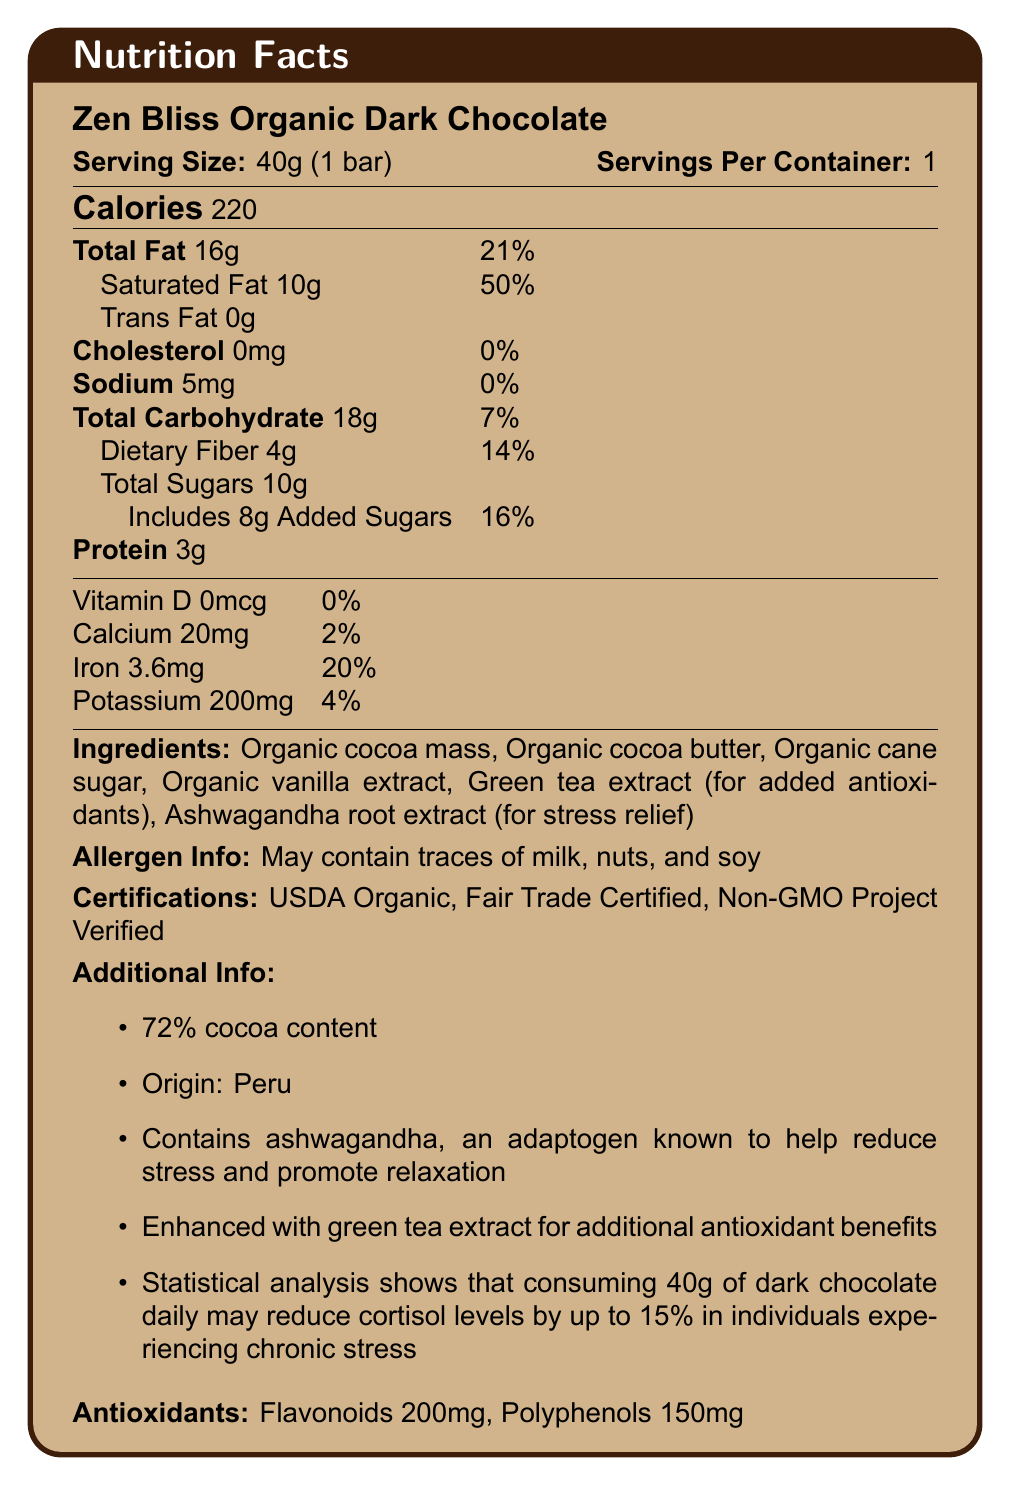what is the serving size of Zen Bliss Organic Dark Chocolate? The serving size is clearly stated at the beginning of the document as "Serving Size: 40g (1 bar)".
Answer: 40g (1 bar) how many calories are in one serving of Zen Bliss Organic Dark Chocolate? The calorie content per serving is listed as "Calories: 220" in the document.
Answer: 220 what are the antioxidants present in the chocolate bar and their amounts? Under the section titled "Antioxidants", it lists "Flavonoids: 200mg" and "Polyphenols: 150mg".
Answer: Flavonoids: 200mg, Polyphenols: 150mg what is the percentage daily value of iron in the chocolate bar? The daily value of iron is indicated as "Iron 3.6mg: 20%" in the nutritional information section.
Answer: 20% how much added sugars does the chocolate bar contain? The document specifies "Includes 8g Added Sugars" in the carbohydrate details.
Answer: 8g does the chocolate bar contain any cholesterol? The entry for cholesterol states "Cholesterol 0mg: 0%" indicating that it contains no cholesterol.
Answer: No which of the following ingredients is added for stress relief? A. Organic cane sugar B. Green tea extract C. Ashwagandha root extract D. Organic vanilla extract Ashwagandha root extract is noted for its stress relief properties in the ingredients list and additional info.
Answer: C. Ashwagandha root extract which certifications does the Zen Bliss Organic Dark Chocolate have? A. USDA Organic, Fair Trade Certified B. USDA Organic, Gluten-Free C. Fair Trade Certified, Non-GMO Project Verified D. USDA Organic, Fair Trade Certified, Non-GMO Project Verified The document lists "USDA Organic, Fair Trade Certified, Non-GMO Project Verified" under the Certifications section.
Answer: D is there any trans fat in the chocolate bar? The document explicitly states "Trans Fat 0g", indicating there is no trans fat.
Answer: No summarize the main information of Zen Bliss Organic Dark Chocolate. This summary covers all the major components including nutritional information, ingredients, added benefits, allergens, and certifications.
Answer: Zen Bliss Organic Dark Chocolate is an organic, fair trade certified dark chocolate bar with 72% cocoa content. Each 40g serving contains 220 calories, 16g total fat (50% of which is saturated), and no cholesterol. It includes 18g of carbohydrates, 4g of dietary fiber, and 10g of sugars (with 8g of added sugars). It also contains antioxidants like flavonoids (200mg) and polyphenols (150mg), enhanced with green tea extract for added antioxidant benefits and ashwagandha for stress relief. The bar is made with ingredients like organic cocoa mass, cocoa butter, and cane sugar, and may contain traces of milk, nuts, and soy. where is the country of origin for Zen Bliss Organic Dark Chocolate? The country of origin is listed under "Additional Info" as "Origin: Peru".
Answer: Peru what is the cocoa content of Zen Bliss Organic Dark Chocolate? The cocoa content is specified as "72%" under the Additional Info section.
Answer: 72% how does consuming 40g of the chocolate bar daily impact cortisol levels? The document mentions that statistical analysis shows a 15% reduction in cortisol levels may occur in individuals experiencing chronic stress who consume 40g of the chocolate daily.
Answer: May reduce cortisol levels by up to 15% what is the daily percentage value of potassium in the chocolate bar? The daily value of potassium is listed as "Potassium 200mg: 4%".
Answer: 4% how much saturated fat is in the chocolate bar per serving? The amount of saturated fat per serving is noted as "Saturated Fat 10g" in the nutritional information.
Answer: 10g what benefits does ashwagandha in the chocolate bar provide? According to the "Additional Info" section, ashwagandha is an adaptogen known to help reduce stress and promote relaxation.
Answer: Stress relief and promotes relaxation does the document mention the effect of Zen Bliss Organic Dark Chocolate on weight loss? The document does not mention any information regarding weight loss.
Answer: Cannot be determined 